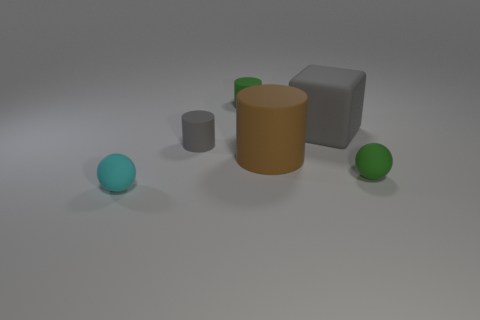There is a brown object that is the same material as the cyan thing; what size is it?
Make the answer very short. Large. There is a large brown rubber object that is on the right side of the tiny ball that is in front of the tiny green matte ball; what shape is it?
Offer a terse response. Cylinder. Are there fewer large brown matte objects than brown matte balls?
Your response must be concise. No. What size is the cylinder that is behind the big brown matte cylinder and in front of the big gray matte cube?
Your answer should be very brief. Small. Does the green rubber ball have the same size as the brown matte thing?
Your answer should be compact. No. There is a tiny rubber cylinder in front of the large matte cube; is it the same color as the cube?
Your response must be concise. Yes. There is a tiny gray cylinder; how many objects are in front of it?
Give a very brief answer. 3. Is the number of tiny green matte objects greater than the number of small gray things?
Offer a terse response. Yes. There is a tiny object that is both left of the small green cylinder and behind the big brown object; what is its shape?
Ensure brevity in your answer.  Cylinder. Is there a large purple matte block?
Give a very brief answer. No. 